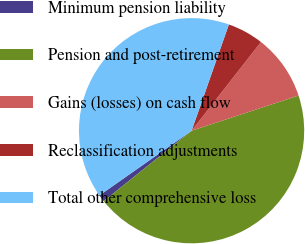<chart> <loc_0><loc_0><loc_500><loc_500><pie_chart><fcel>Minimum pension liability<fcel>Pension and post-retirement<fcel>Gains (losses) on cash flow<fcel>Reclassification adjustments<fcel>Total other comprehensive loss<nl><fcel>1.01%<fcel>44.3%<fcel>9.38%<fcel>5.19%<fcel>40.11%<nl></chart> 